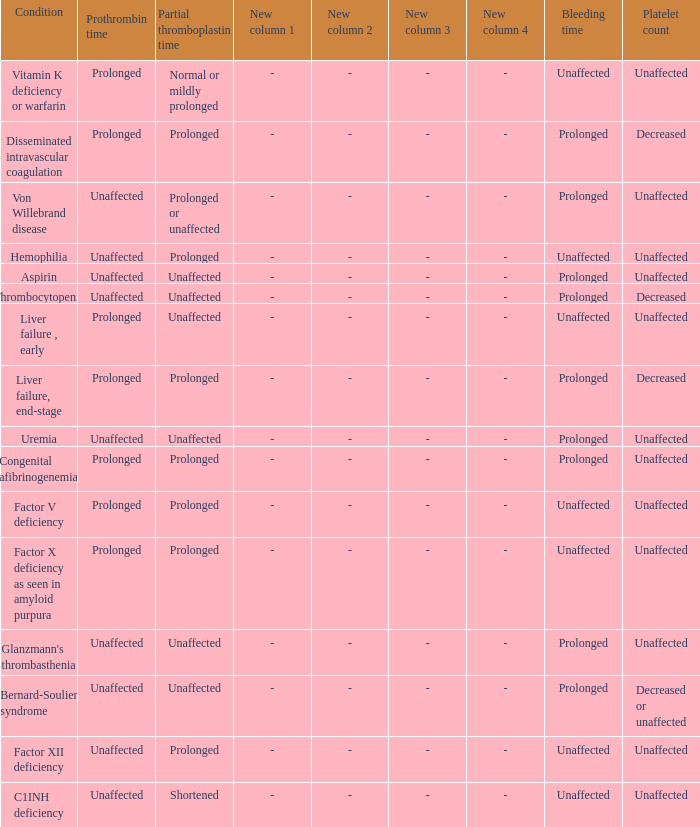What is hemophilia's bleeding time? Unaffected. 